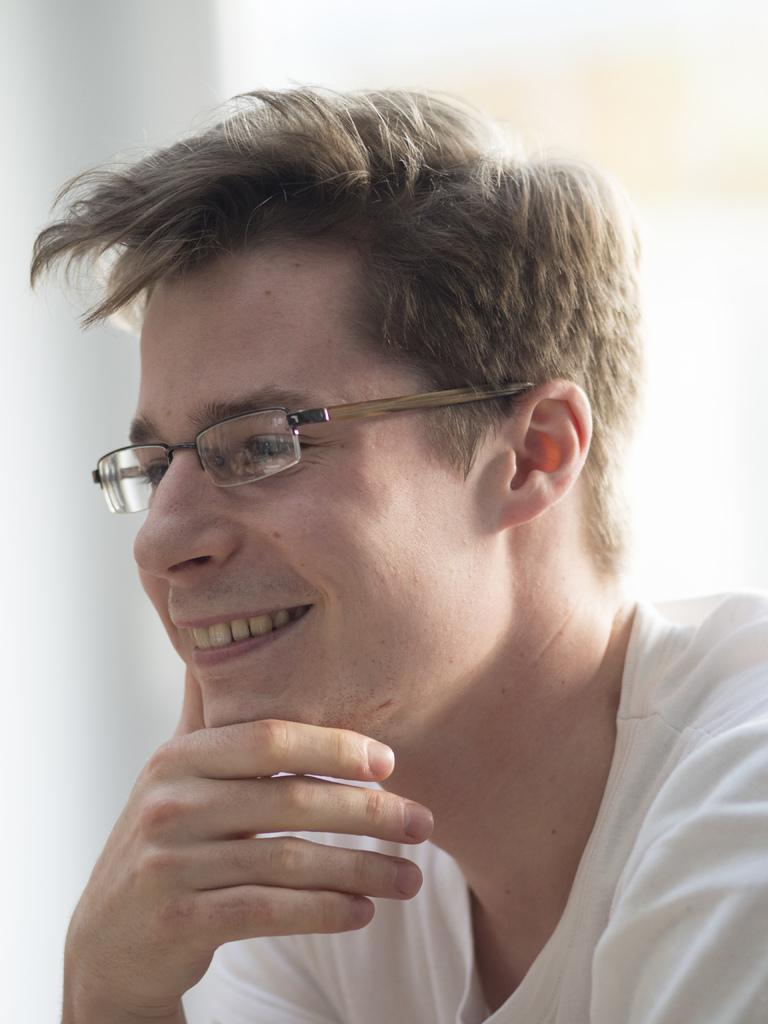What is present in the image? There is a person in the image. Can you describe the person's appearance? The person is wearing spectacles. What is the person's facial expression? The person is smiling. Where is the desk located in the image? There is no desk present in the image. What type of beast can be seen interacting with the person in the image? There is no beast present in the image. 